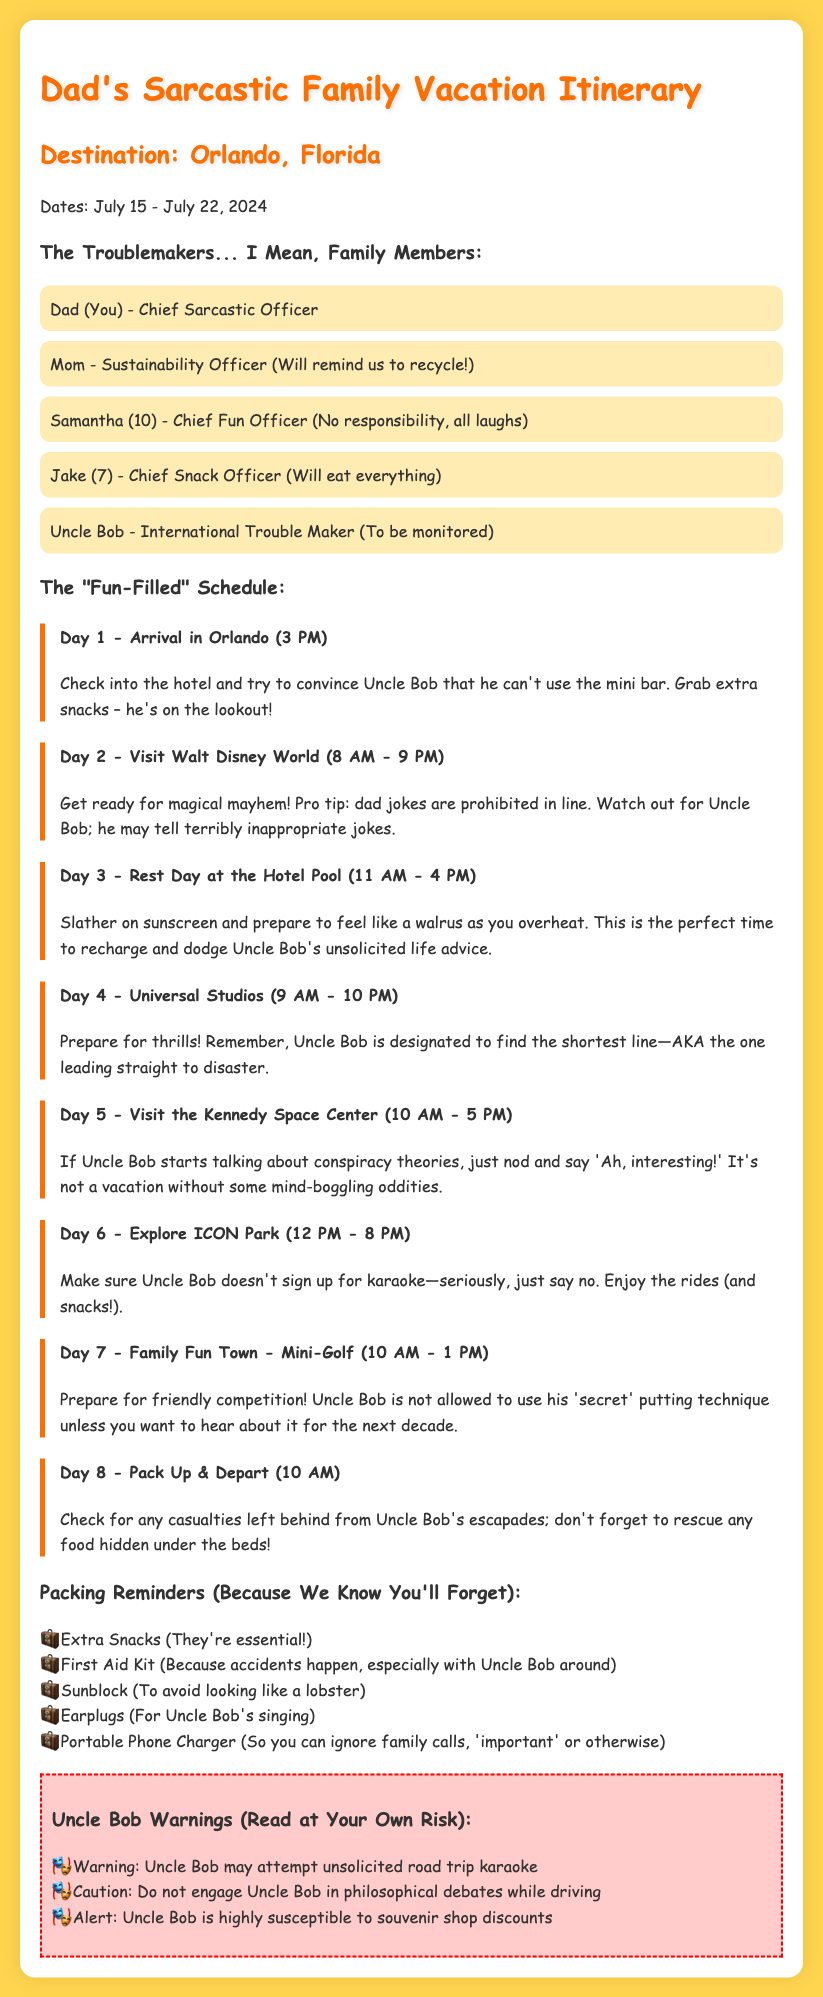What is the destination of the family vacation? The destination is mentioned at the beginning of the itinerary under "Destination."
Answer: Orlando, Florida What is the date range of the vacation? The date range is specified right after the destination.
Answer: July 15 - July 22, 2024 Who is the Chief Fun Officer? The Chief Fun Officer is listed among family members.
Answer: Samantha What time does Day 2 start? The start time for Day 2 is included in the schedule.
Answer: 8 AM How long is the visit to Kennedy Space Center planned for? The duration of the visit is stated in the itinerary for Day 5.
Answer: 10 AM - 5 PM What important item should be packed according to the reminders? The packing reminders include several essential items; one key item is highlighted.
Answer: Extra Snacks What is Uncle Bob designated to find at Universal Studios? This is mentioned in the itinerary for Day 4.
Answer: Shortest line What type of music should you be wary of during the trip? The document mentions a specific activity that might involve music.
Answer: Karaoke What do you need to check for on Day 8 before departing? The document provides a hint of what to look for regarding Uncle Bob.
Answer: Casualties left behind 